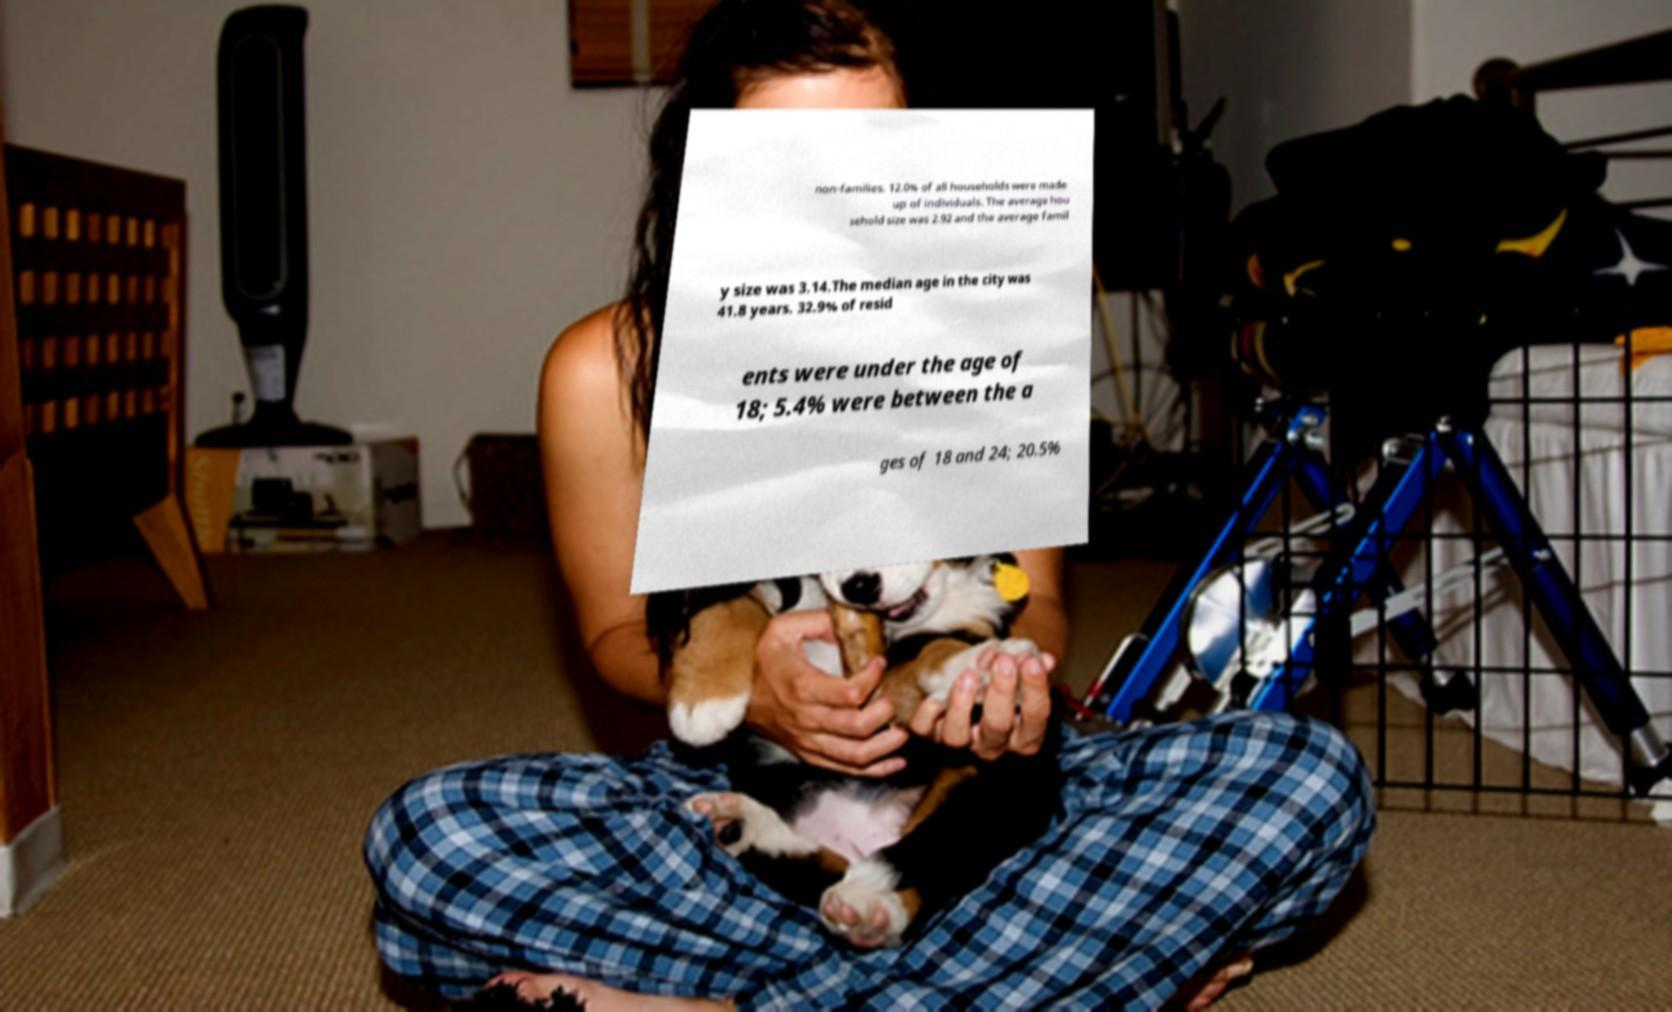There's text embedded in this image that I need extracted. Can you transcribe it verbatim? non-families. 12.0% of all households were made up of individuals. The average hou sehold size was 2.92 and the average famil y size was 3.14.The median age in the city was 41.8 years. 32.9% of resid ents were under the age of 18; 5.4% were between the a ges of 18 and 24; 20.5% 